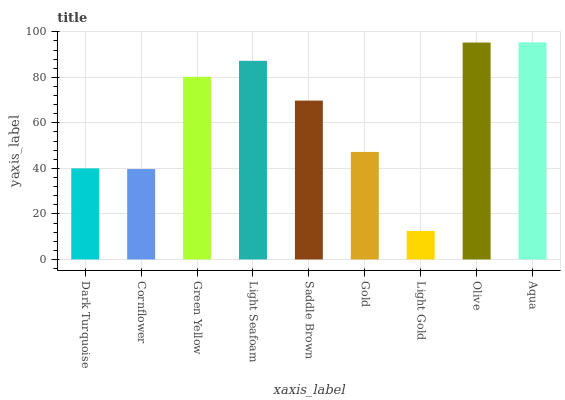Is Light Gold the minimum?
Answer yes or no. Yes. Is Aqua the maximum?
Answer yes or no. Yes. Is Cornflower the minimum?
Answer yes or no. No. Is Cornflower the maximum?
Answer yes or no. No. Is Dark Turquoise greater than Cornflower?
Answer yes or no. Yes. Is Cornflower less than Dark Turquoise?
Answer yes or no. Yes. Is Cornflower greater than Dark Turquoise?
Answer yes or no. No. Is Dark Turquoise less than Cornflower?
Answer yes or no. No. Is Saddle Brown the high median?
Answer yes or no. Yes. Is Saddle Brown the low median?
Answer yes or no. Yes. Is Light Seafoam the high median?
Answer yes or no. No. Is Olive the low median?
Answer yes or no. No. 